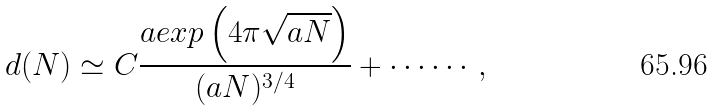Convert formula to latex. <formula><loc_0><loc_0><loc_500><loc_500>d ( N ) \simeq C \frac { a e x p \left ( 4 \pi \sqrt { a N } \right ) } { ( a N ) ^ { 3 / 4 } } + \cdots \cdots ,</formula> 